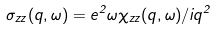<formula> <loc_0><loc_0><loc_500><loc_500>\sigma _ { z z } ( q , \omega ) = e ^ { 2 } \omega \chi _ { z z } ( q , \omega ) / i q ^ { 2 }</formula> 